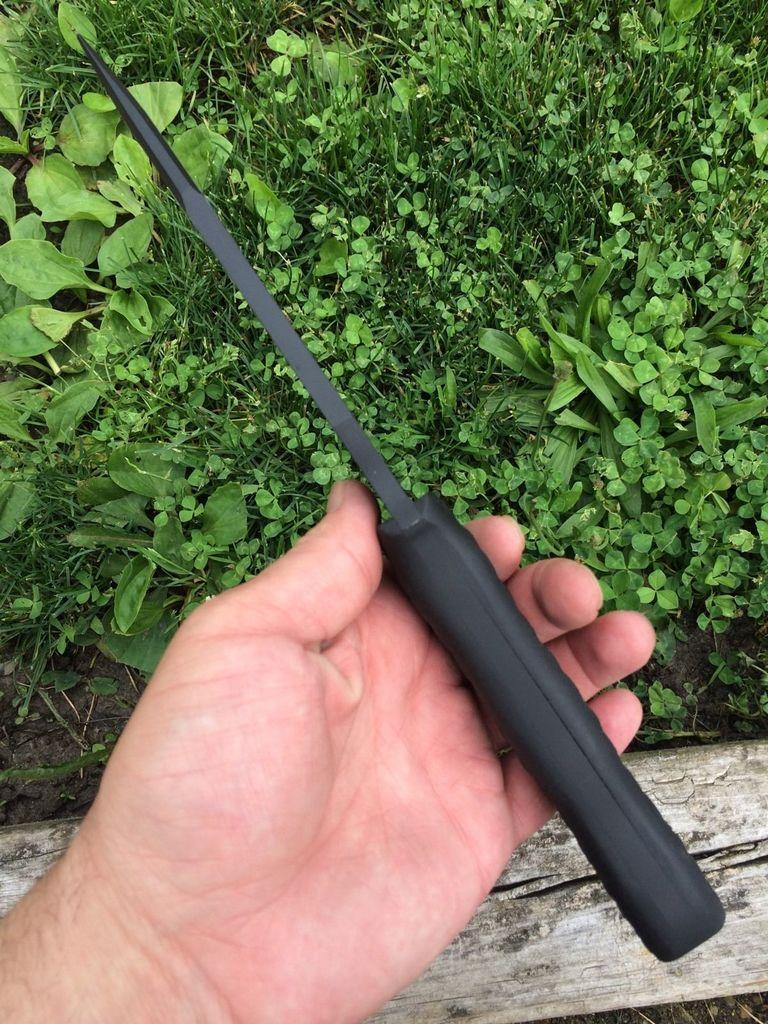What part of the human body is visible in the image? There is a human hand in the image. What is the hand doing in the image? The hand is holding an object. What type of material is the wooden stick made of? The wooden stick in the image is made of wood. What type of vegetation can be seen in the image? There is grass in the image. What color is the orange that the hand is holding in the image? There is no orange present in the image; the hand is holding an unspecified object. 